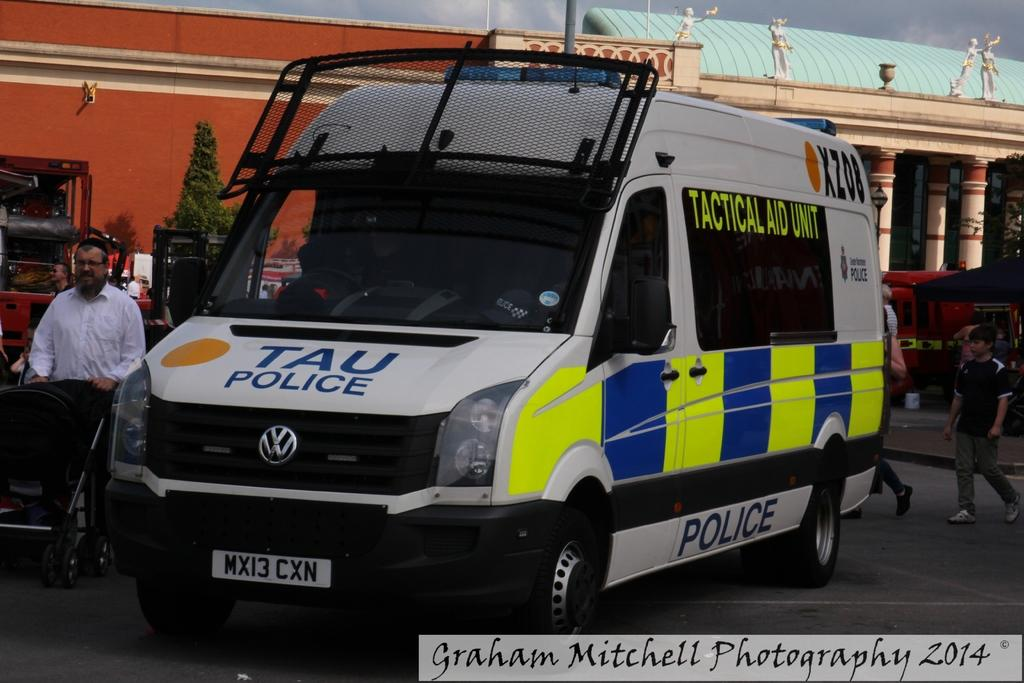Provide a one-sentence caption for the provided image. A TAU Police vehicle parked in a parking lot taken by Graham Mitchell Photography 2014. 